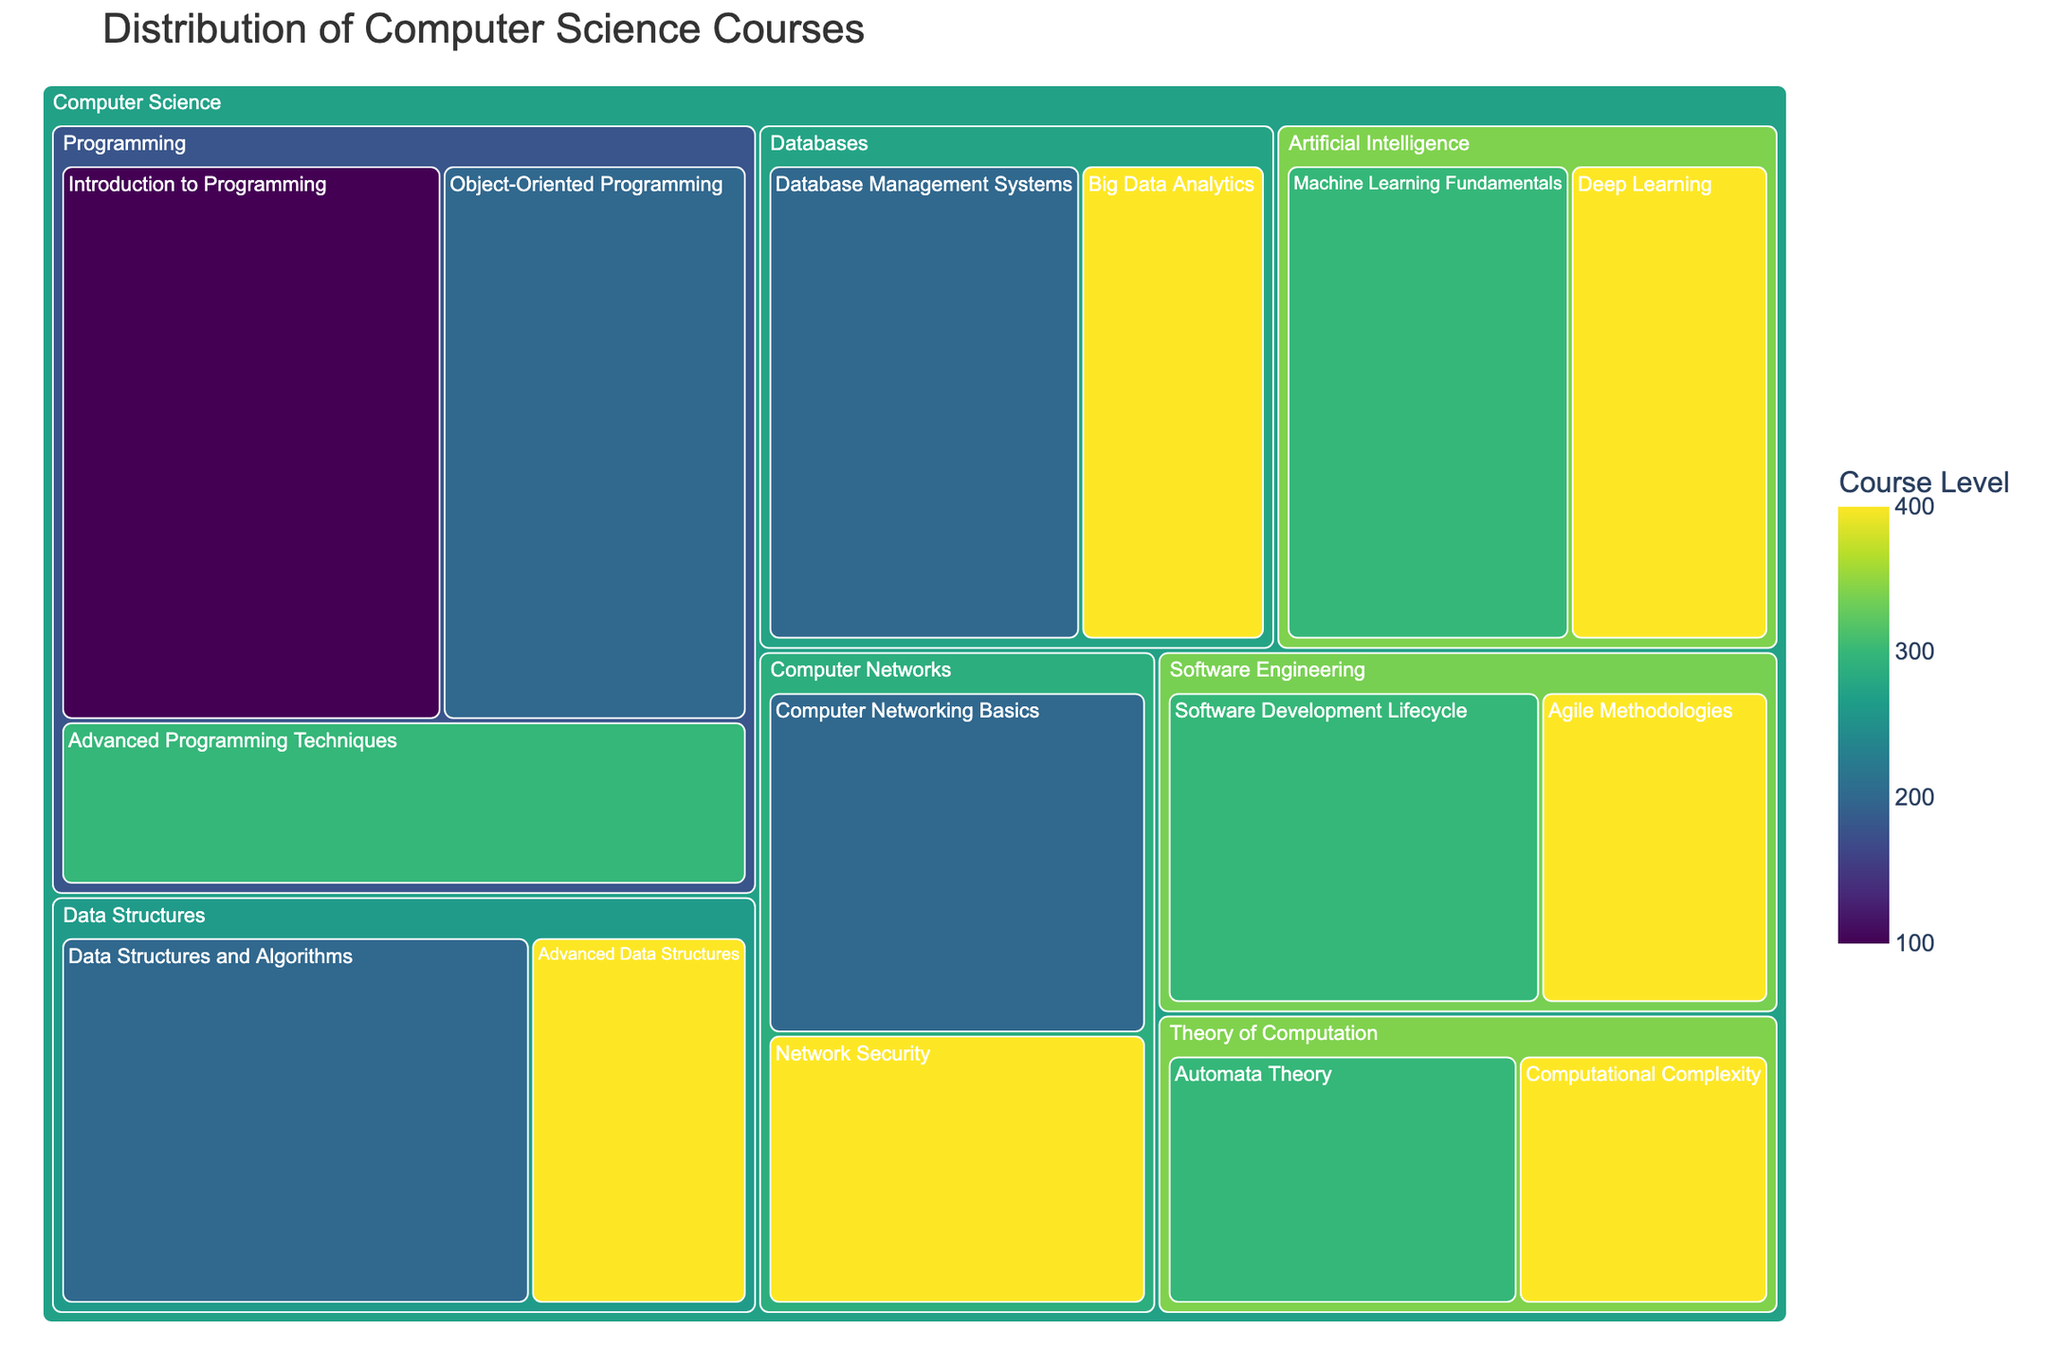How many specialization areas are visualized in the treemap? The treemap divides the data into different specialization areas from Computer Science, which form distinct sections in the figure. Each section corresponds to a specialization area. Count the sections to find out the answer.
Answer: 6 Which course has the highest enrollment, and what is its specialization? To find the course with the highest enrollment, locate the largest rectangle, which should visually dominate others. Check the label and specialization associated with this rectangle.
Answer: Introduction to Programming, Programming What is the total enrollment for courses under the Artificial Intelligence specialization? Locate the section for Artificial Intelligence specialization. This section contains two courses: Machine Learning Fundamentals and Deep Learning. Add their enrollments together (100 from Machine Learning Fundamentals and 70 from Deep Learning).
Answer: 170 Compare the enrollments of Data Structures and Algorithms and Advanced Data Structures. Which one has the higher enrollment? Locate the two courses within the Data Structures specialization section. Note their enrollments, 130 for Data Structures and Algorithms, and 60 for Advanced Data Structures. Compare these values directly.
Answer: Data Structures and Algorithms What is the average enrollment of level 400 courses across all specializations? Identify all level 400 courses: Advanced Data Structures, Deep Learning, Big Data Analytics, Agile Methodologies, Network Security, Computational Complexity. Sum their enrollments (60 + 70 + 65 + 55 + 75 + 50 = 375) and divide by the number of courses (6).
Answer: 62.5 Which specialization has the lowest total enrollment and what is its value? Check the total area of each specialization section relative to others, starting from the smallest section. Add up the values in the smallest section to find the total enrollment for that specialization.
Answer: Theory of Computation, 120 How many courses are at level 300? Look for rectangles colored in level 300 color (specific to the color scheme used), and count them. Each rectangle of this color represents a course at level 300.
Answer: 4 Are there any specializations where all courses are at the same level? If yes, name the specialization and the level. Examine each specialization section to see if all rectangles within a section have the same color, which corresponds to a specific level.
Answer: Theory of Computation, 400 Which course has the lowest enrollment, and what is its specialization and level? Locate the smallest rectangle in the treemap. The label on this rectangle provides the course name, with specialization and level found within its section.
Answer: Computational Complexity, Theory of Computation, 400 